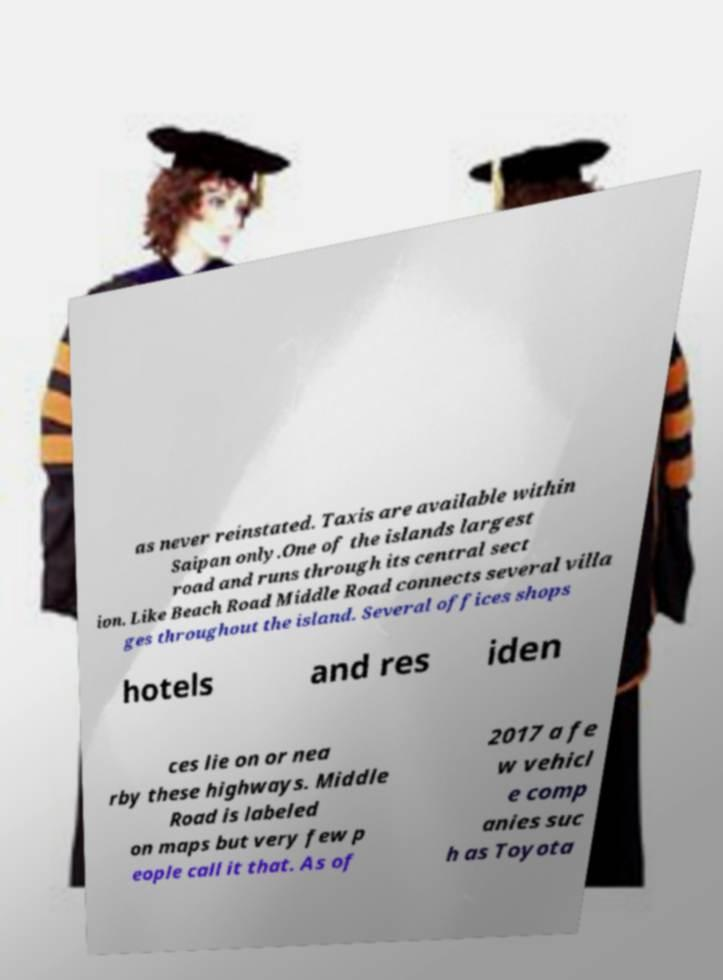What messages or text are displayed in this image? I need them in a readable, typed format. as never reinstated. Taxis are available within Saipan only.One of the islands largest road and runs through its central sect ion. Like Beach Road Middle Road connects several villa ges throughout the island. Several offices shops hotels and res iden ces lie on or nea rby these highways. Middle Road is labeled on maps but very few p eople call it that. As of 2017 a fe w vehicl e comp anies suc h as Toyota 